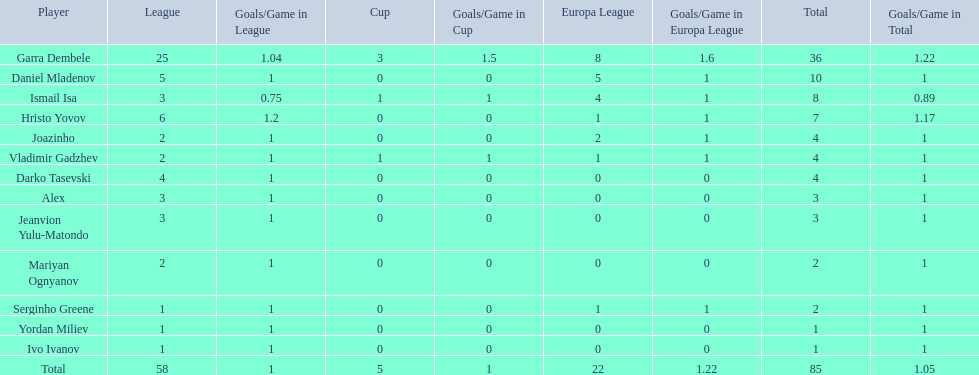What is the combined total of the cup and europa league? 27. Would you be able to parse every entry in this table? {'header': ['Player', 'League', 'Goals/Game in League', 'Cup', 'Goals/Game in Cup', 'Europa League', 'Goals/Game in Europa League', 'Total', 'Goals/Game in Total'], 'rows': [['Garra Dembele', '25', '1.04', '3', '1.5', '8', '1.6', '36', '1.22'], ['Daniel Mladenov', '5', '1', '0', '0', '5', '1', '10', '1'], ['Ismail Isa', '3', '0.75', '1', '1', '4', '1', '8', '0.89'], ['Hristo Yovov', '6', '1.2', '0', '0', '1', '1', '7', '1.17'], ['Joazinho', '2', '1', '0', '0', '2', '1', '4', '1'], ['Vladimir Gadzhev', '2', '1', '1', '1', '1', '1', '4', '1'], ['Darko Tasevski', '4', '1', '0', '0', '0', '0', '4', '1'], ['Alex', '3', '1', '0', '0', '0', '0', '3', '1'], ['Jeanvion Yulu-Matondo', '3', '1', '0', '0', '0', '0', '3', '1'], ['Mariyan Ognyanov', '2', '1', '0', '0', '0', '0', '2', '1'], ['Serginho Greene', '1', '1', '0', '0', '1', '1', '2', '1'], ['Yordan Miliev', '1', '1', '0', '0', '0', '0', '1', '1'], ['Ivo Ivanov', '1', '1', '0', '0', '0', '0', '1', '1'], ['Total', '58', '1', '5', '1', '22', '1.22', '85', '1.05']]} 